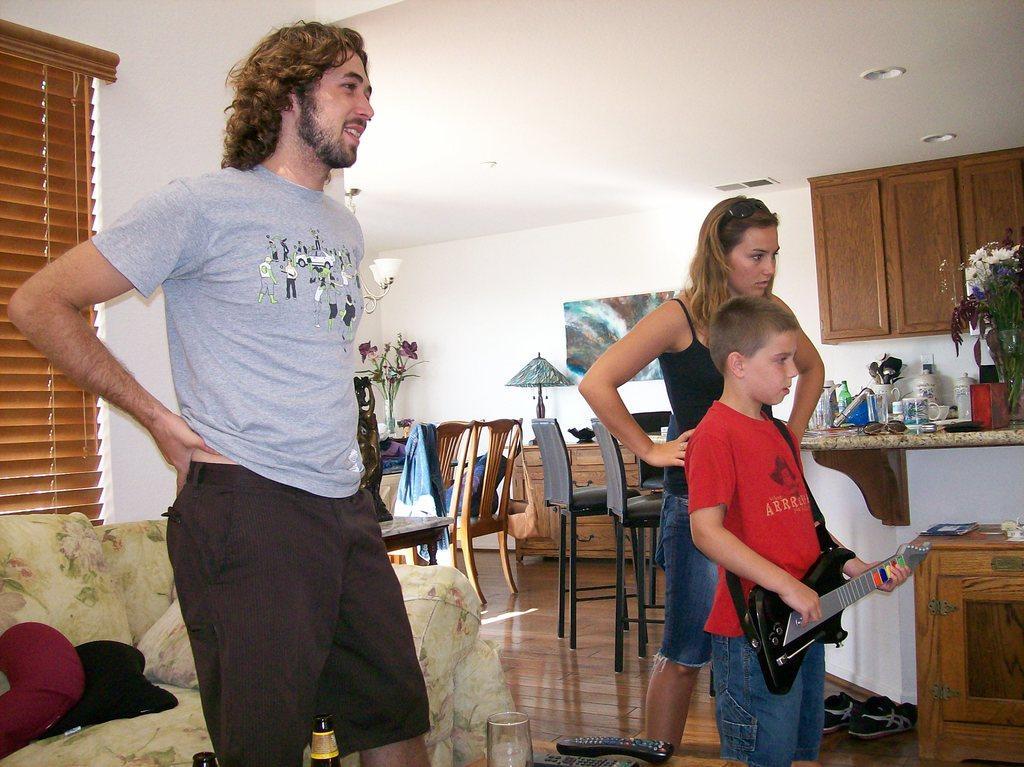How would you summarize this image in a sentence or two? In a room there is a man and woman and a boy who is holding guitar. Beside him there is a table with cups and flower vase. 